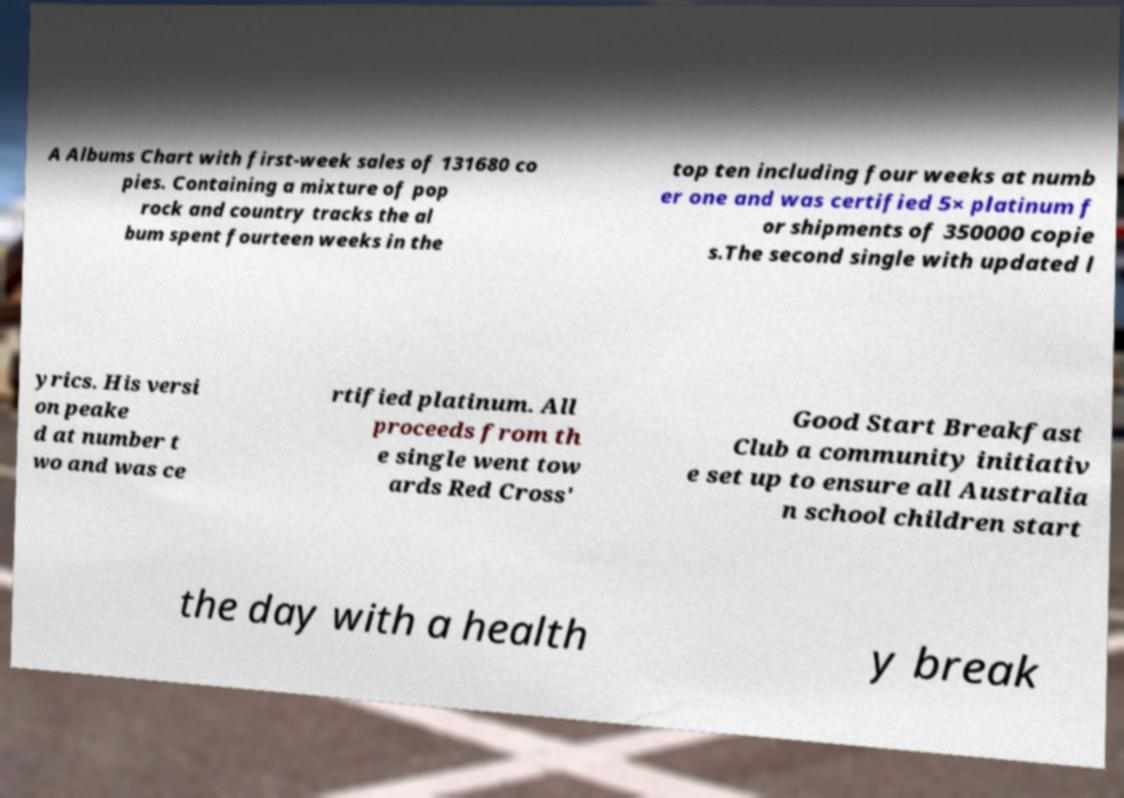What messages or text are displayed in this image? I need them in a readable, typed format. A Albums Chart with first-week sales of 131680 co pies. Containing a mixture of pop rock and country tracks the al bum spent fourteen weeks in the top ten including four weeks at numb er one and was certified 5× platinum f or shipments of 350000 copie s.The second single with updated l yrics. His versi on peake d at number t wo and was ce rtified platinum. All proceeds from th e single went tow ards Red Cross' Good Start Breakfast Club a community initiativ e set up to ensure all Australia n school children start the day with a health y break 